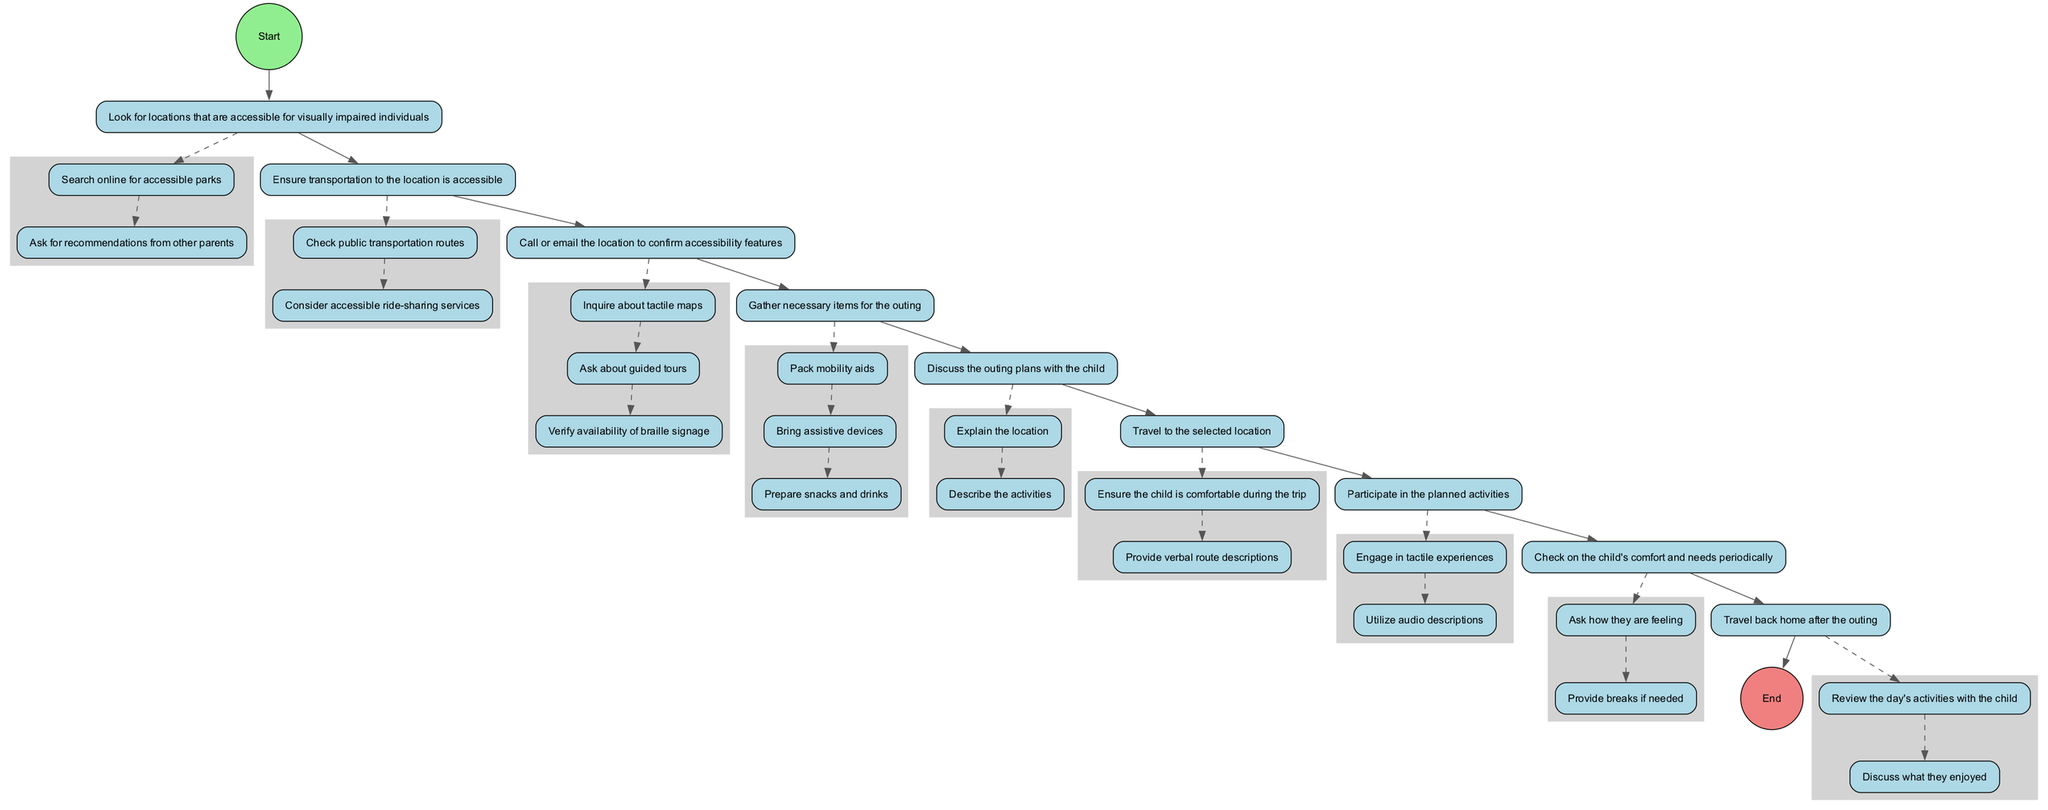What is the first step in the outing planning process? The diagram starts with the "Start" node, which indicates the beginning of the outing planning process. The next step is labeled "Research Accessible Locations." Therefore, the first step is to begin the planning process.
Answer: Begin the plan for the outing How many actions are listed under "Contact Location"? Under the "Contact Location" node, there are three actions described: inquire about tactile maps, ask about guided tours, and verify availability of braille signage. Thus, there are three actions listed.
Answer: 3 Which node comes after "Prepare Outing Kit"? The flow of the diagram shows that after the "Prepare Outing Kit" node, the next node is "Inform Child In Advance." This follows the order of the nodes connected by edges.
Answer: Inform Child In Advance What is the last action described under "Enjoy Activities"? The last action under the "Enjoy Activities" node is to utilize audio descriptions. This is the final action listed for that particular node in the diagram.
Answer: Utilize audio descriptions What do you need to check regarding transportation options? The "Check Transportation Options" node indicates that the required checks are public transportation routes and accessible ride-sharing services. Both aspects are essential to ensure accessible transportation.
Answer: Check public transportation routes, consider accessible ride-sharing services What must be verified when contacting the location? When contacting the location, it is important to verify the availability of braille signage, inquire about tactile maps, and ask about guided tours. All these details contribute to confirming accessibility features.
Answer: Verify availability of braille signage What node precedes "Travel To Location"? In the sequence of nodes in the diagram, "Prepare Outing Kit" precedes "Travel To Location." This implies that gathering necessary items must be done before beginning the travel.
Answer: Prepare Outing Kit How is child comfort monitored during the outing? The "Monitor Child Comfort" node specifies that checking on the child's comfort and needs periodically involves asking how they are feeling and providing breaks if needed. This approach ensures the child's well-being.
Answer: Ask how they are feeling, provide breaks if needed 